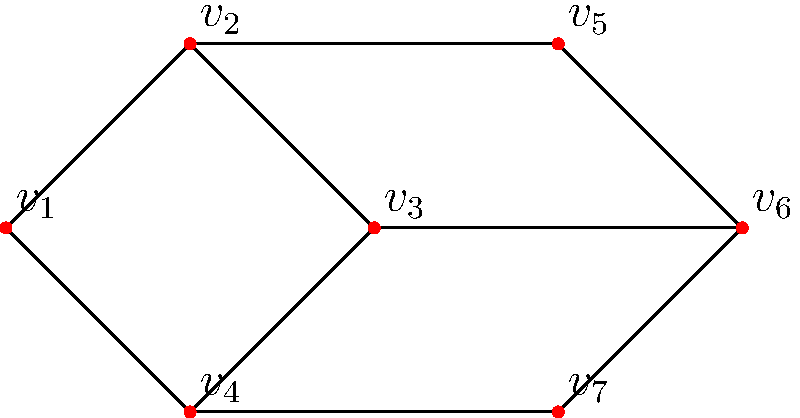In the Strelley village neighborhood watch program, you want to organize watch zones efficiently. The graph represents different areas of the village, where vertices are key locations and edges are paths between them. What is the minimum number of watch captains needed to cover all locations if each captain can monitor their location and all directly connected locations? To solve this problem, we need to find the minimum dominating set of the graph. A dominating set is a subset of vertices such that every vertex in the graph is either in the set or adjacent to a vertex in the set. The steps to find the solution are:

1. Analyze the graph structure:
   - The graph has 7 vertices (v1 to v7) and 9 edges.
   - It consists of two connected components: a square (v1-v2-v3-v4) and a larger component.

2. Identify key vertices:
   - v2 and v5 are connected to four other vertices each, making them strategic choices.
   - Selecting v2 covers v1, v2, v3, and v4.
   - Selecting v5 covers v2, v4, v5, v6, and v7.

3. Check for complete coverage:
   - v2 and v5 together cover all vertices except v3.
   - We need one more vertex to cover v3, which can be either v3 itself or v6.

4. Optimize the selection:
   - Choosing v6 is more efficient as it reinforces coverage of v5 and v7.

5. Verify the solution:
   - The set {v2, v5, v6} covers all vertices in the graph.
   - No smaller set can cover all vertices.

Therefore, the minimum number of watch captains needed is 3, positioned at locations v2, v5, and v6.
Answer: 3 watch captains 